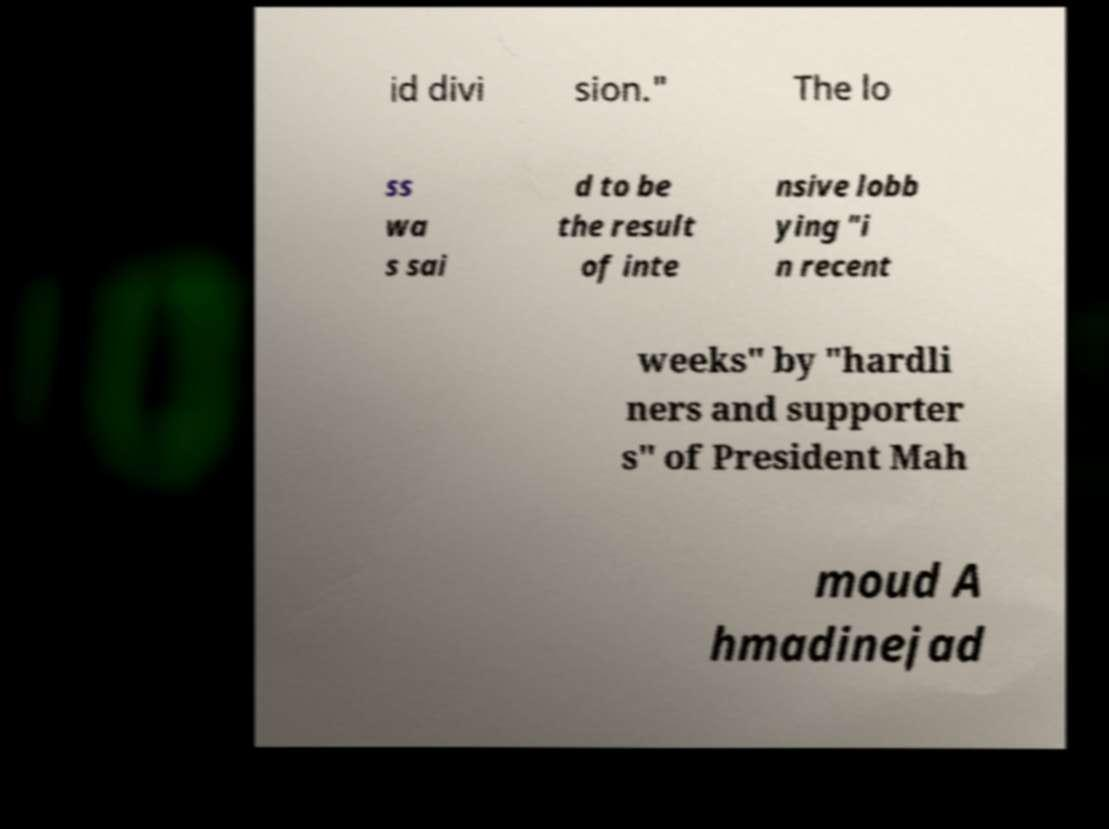Please read and relay the text visible in this image. What does it say? id divi sion." The lo ss wa s sai d to be the result of inte nsive lobb ying "i n recent weeks" by "hardli ners and supporter s" of President Mah moud A hmadinejad 